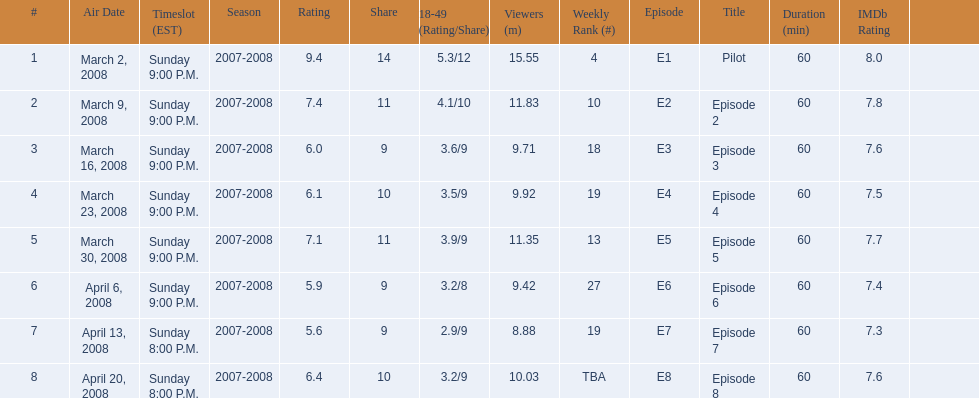Did the season finish at an earlier or later timeslot? Earlier. 